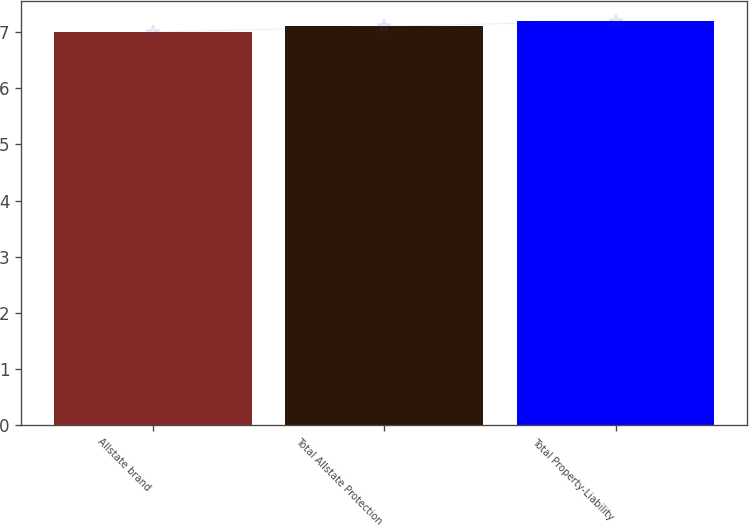Convert chart to OTSL. <chart><loc_0><loc_0><loc_500><loc_500><bar_chart><fcel>Allstate brand<fcel>Total Allstate Protection<fcel>Total Property-Liability<nl><fcel>7<fcel>7.1<fcel>7.2<nl></chart> 